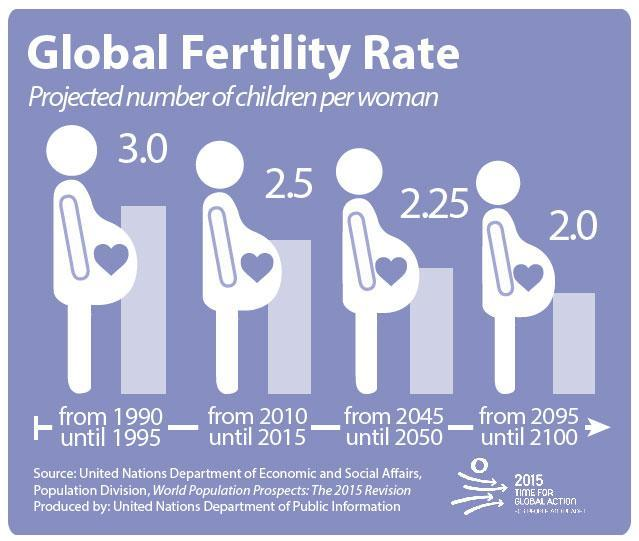What is the global fertility rate from 2010 until 2015?
Answer the question with a short phrase. 2.5 